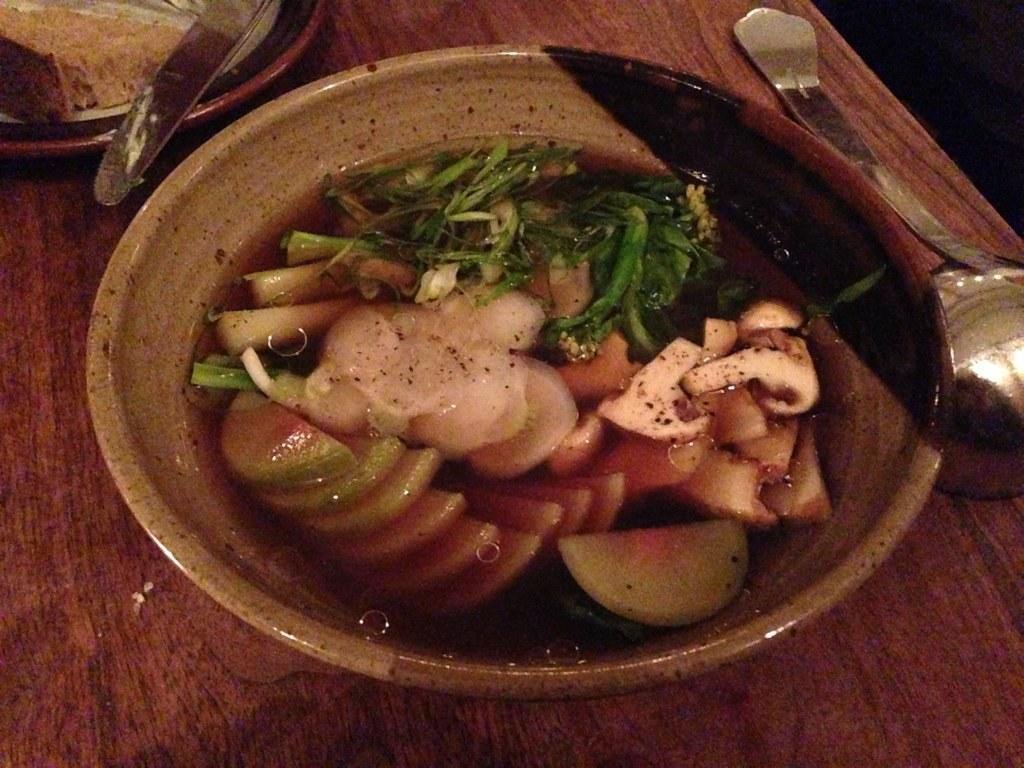Please provide a concise description of this image. In the picture I can see the wooden table. I can see a bowl, a plate and stainless steel cookware handle on the table. I can see the vegetables and water in the bowl. 